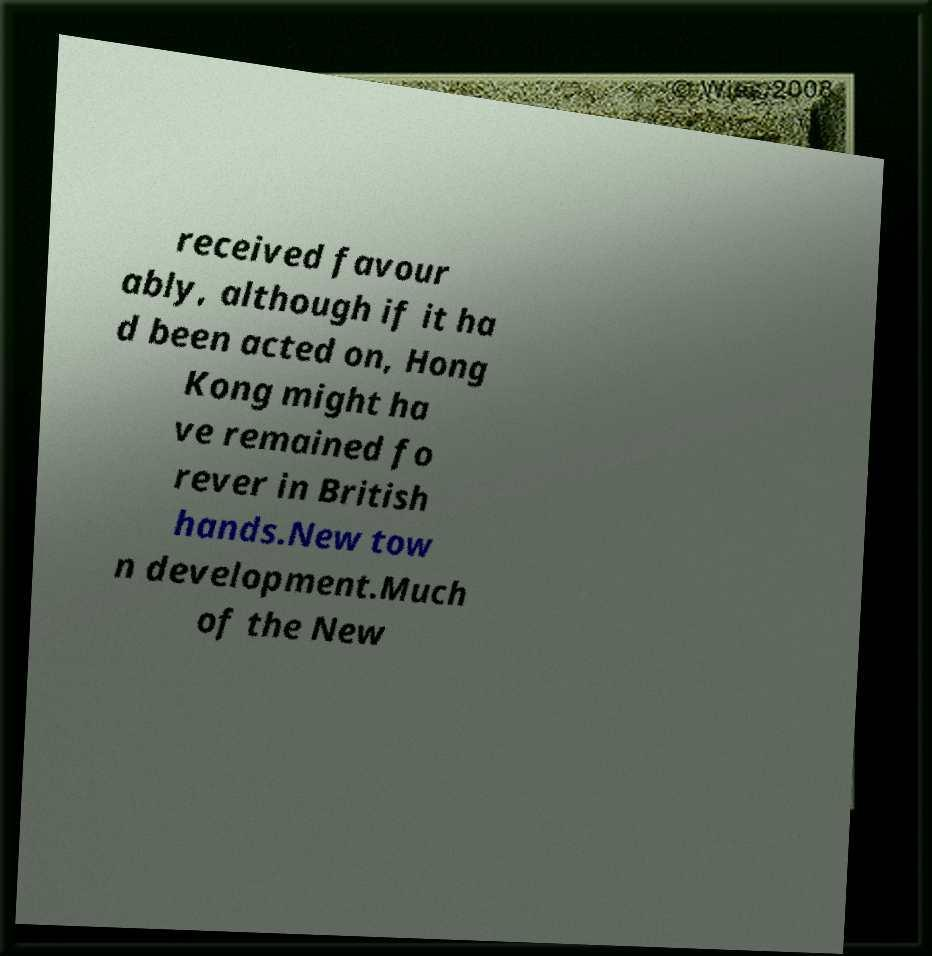Please read and relay the text visible in this image. What does it say? received favour ably, although if it ha d been acted on, Hong Kong might ha ve remained fo rever in British hands.New tow n development.Much of the New 